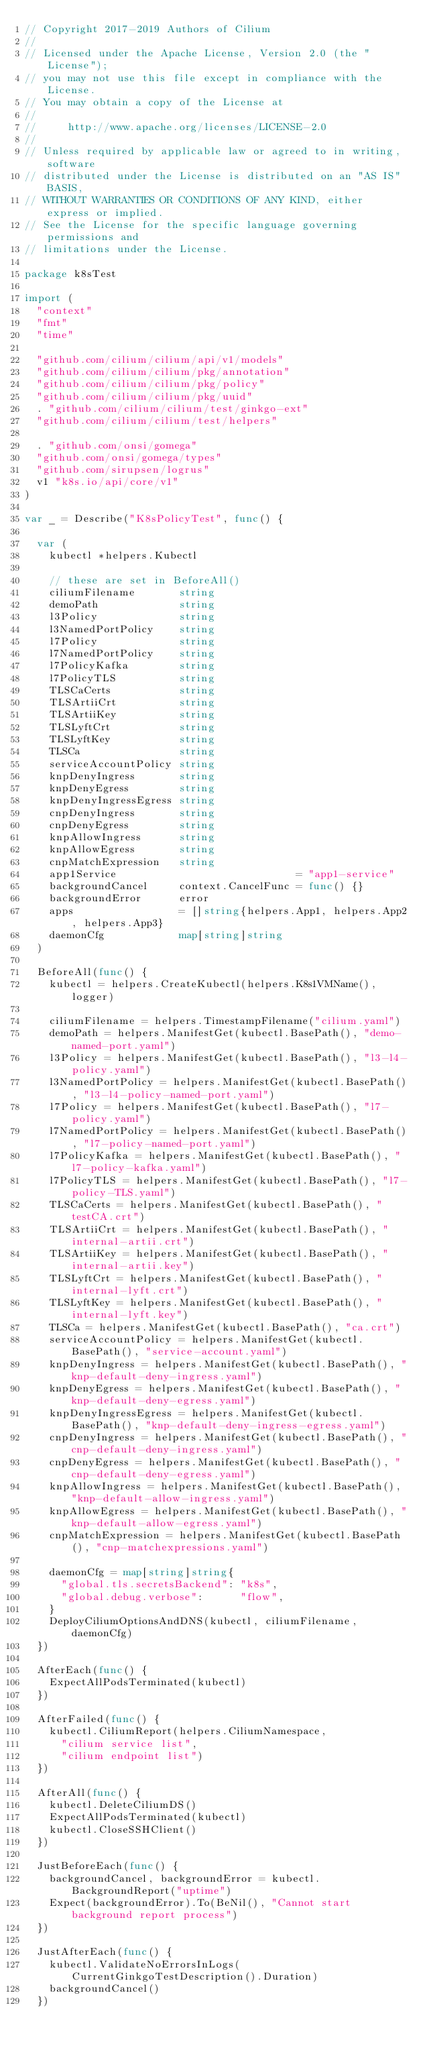<code> <loc_0><loc_0><loc_500><loc_500><_Go_>// Copyright 2017-2019 Authors of Cilium
//
// Licensed under the Apache License, Version 2.0 (the "License");
// you may not use this file except in compliance with the License.
// You may obtain a copy of the License at
//
//     http://www.apache.org/licenses/LICENSE-2.0
//
// Unless required by applicable law or agreed to in writing, software
// distributed under the License is distributed on an "AS IS" BASIS,
// WITHOUT WARRANTIES OR CONDITIONS OF ANY KIND, either express or implied.
// See the License for the specific language governing permissions and
// limitations under the License.

package k8sTest

import (
	"context"
	"fmt"
	"time"

	"github.com/cilium/cilium/api/v1/models"
	"github.com/cilium/cilium/pkg/annotation"
	"github.com/cilium/cilium/pkg/policy"
	"github.com/cilium/cilium/pkg/uuid"
	. "github.com/cilium/cilium/test/ginkgo-ext"
	"github.com/cilium/cilium/test/helpers"

	. "github.com/onsi/gomega"
	"github.com/onsi/gomega/types"
	"github.com/sirupsen/logrus"
	v1 "k8s.io/api/core/v1"
)

var _ = Describe("K8sPolicyTest", func() {

	var (
		kubectl *helpers.Kubectl

		// these are set in BeforeAll()
		ciliumFilename       string
		demoPath             string
		l3Policy             string
		l3NamedPortPolicy    string
		l7Policy             string
		l7NamedPortPolicy    string
		l7PolicyKafka        string
		l7PolicyTLS          string
		TLSCaCerts           string
		TLSArtiiCrt          string
		TLSArtiiKey          string
		TLSLyftCrt           string
		TLSLyftKey           string
		TLSCa                string
		serviceAccountPolicy string
		knpDenyIngress       string
		knpDenyEgress        string
		knpDenyIngressEgress string
		cnpDenyIngress       string
		cnpDenyEgress        string
		knpAllowIngress      string
		knpAllowEgress       string
		cnpMatchExpression   string
		app1Service                             = "app1-service"
		backgroundCancel     context.CancelFunc = func() {}
		backgroundError      error
		apps                 = []string{helpers.App1, helpers.App2, helpers.App3}
		daemonCfg            map[string]string
	)

	BeforeAll(func() {
		kubectl = helpers.CreateKubectl(helpers.K8s1VMName(), logger)

		ciliumFilename = helpers.TimestampFilename("cilium.yaml")
		demoPath = helpers.ManifestGet(kubectl.BasePath(), "demo-named-port.yaml")
		l3Policy = helpers.ManifestGet(kubectl.BasePath(), "l3-l4-policy.yaml")
		l3NamedPortPolicy = helpers.ManifestGet(kubectl.BasePath(), "l3-l4-policy-named-port.yaml")
		l7Policy = helpers.ManifestGet(kubectl.BasePath(), "l7-policy.yaml")
		l7NamedPortPolicy = helpers.ManifestGet(kubectl.BasePath(), "l7-policy-named-port.yaml")
		l7PolicyKafka = helpers.ManifestGet(kubectl.BasePath(), "l7-policy-kafka.yaml")
		l7PolicyTLS = helpers.ManifestGet(kubectl.BasePath(), "l7-policy-TLS.yaml")
		TLSCaCerts = helpers.ManifestGet(kubectl.BasePath(), "testCA.crt")
		TLSArtiiCrt = helpers.ManifestGet(kubectl.BasePath(), "internal-artii.crt")
		TLSArtiiKey = helpers.ManifestGet(kubectl.BasePath(), "internal-artii.key")
		TLSLyftCrt = helpers.ManifestGet(kubectl.BasePath(), "internal-lyft.crt")
		TLSLyftKey = helpers.ManifestGet(kubectl.BasePath(), "internal-lyft.key")
		TLSCa = helpers.ManifestGet(kubectl.BasePath(), "ca.crt")
		serviceAccountPolicy = helpers.ManifestGet(kubectl.BasePath(), "service-account.yaml")
		knpDenyIngress = helpers.ManifestGet(kubectl.BasePath(), "knp-default-deny-ingress.yaml")
		knpDenyEgress = helpers.ManifestGet(kubectl.BasePath(), "knp-default-deny-egress.yaml")
		knpDenyIngressEgress = helpers.ManifestGet(kubectl.BasePath(), "knp-default-deny-ingress-egress.yaml")
		cnpDenyIngress = helpers.ManifestGet(kubectl.BasePath(), "cnp-default-deny-ingress.yaml")
		cnpDenyEgress = helpers.ManifestGet(kubectl.BasePath(), "cnp-default-deny-egress.yaml")
		knpAllowIngress = helpers.ManifestGet(kubectl.BasePath(), "knp-default-allow-ingress.yaml")
		knpAllowEgress = helpers.ManifestGet(kubectl.BasePath(), "knp-default-allow-egress.yaml")
		cnpMatchExpression = helpers.ManifestGet(kubectl.BasePath(), "cnp-matchexpressions.yaml")

		daemonCfg = map[string]string{
			"global.tls.secretsBackend": "k8s",
			"global.debug.verbose":      "flow",
		}
		DeployCiliumOptionsAndDNS(kubectl, ciliumFilename, daemonCfg)
	})

	AfterEach(func() {
		ExpectAllPodsTerminated(kubectl)
	})

	AfterFailed(func() {
		kubectl.CiliumReport(helpers.CiliumNamespace,
			"cilium service list",
			"cilium endpoint list")
	})

	AfterAll(func() {
		kubectl.DeleteCiliumDS()
		ExpectAllPodsTerminated(kubectl)
		kubectl.CloseSSHClient()
	})

	JustBeforeEach(func() {
		backgroundCancel, backgroundError = kubectl.BackgroundReport("uptime")
		Expect(backgroundError).To(BeNil(), "Cannot start background report process")
	})

	JustAfterEach(func() {
		kubectl.ValidateNoErrorsInLogs(CurrentGinkgoTestDescription().Duration)
		backgroundCancel()
	})
</code> 